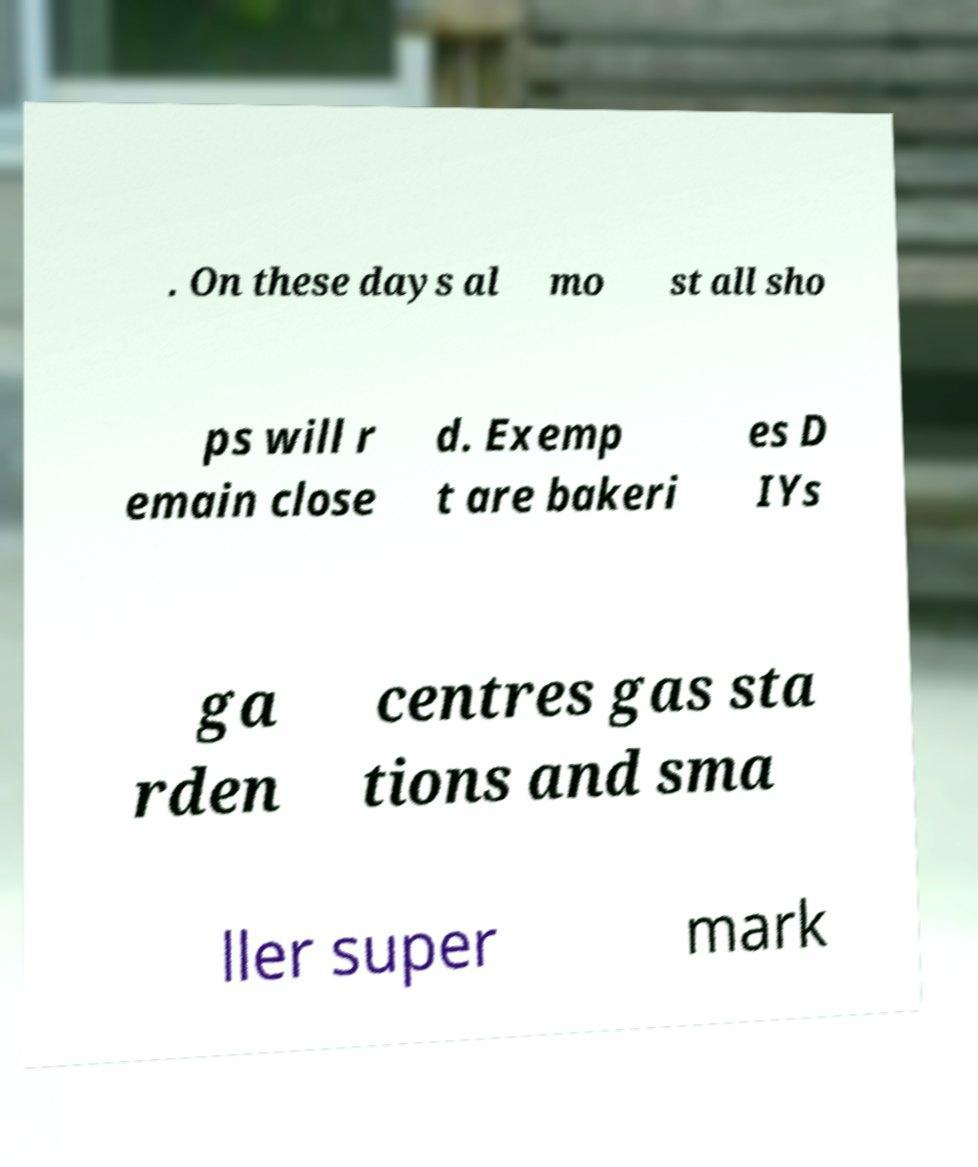Please identify and transcribe the text found in this image. . On these days al mo st all sho ps will r emain close d. Exemp t are bakeri es D IYs ga rden centres gas sta tions and sma ller super mark 